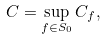<formula> <loc_0><loc_0><loc_500><loc_500>C = \sup _ { f \in S _ { 0 } } C _ { f } ,</formula> 